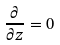Convert formula to latex. <formula><loc_0><loc_0><loc_500><loc_500>\frac { \partial } { \partial z } = 0</formula> 